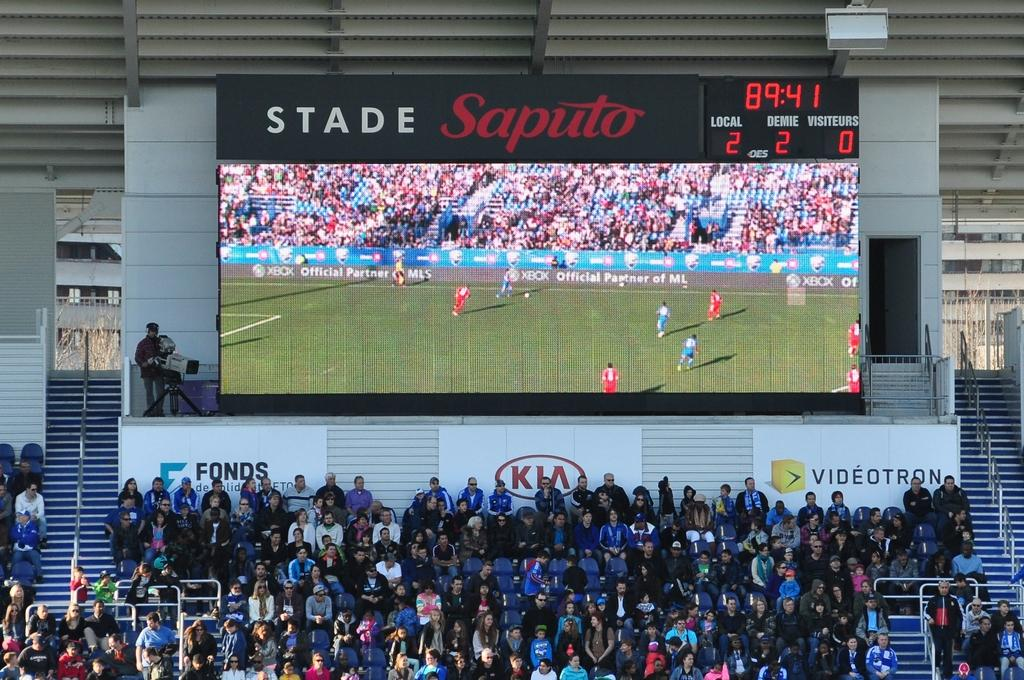Provide a one-sentence caption for the provided image. Many people are sitting at a stadium with the score board above them showing the soccer game and says Stand Saputo. 